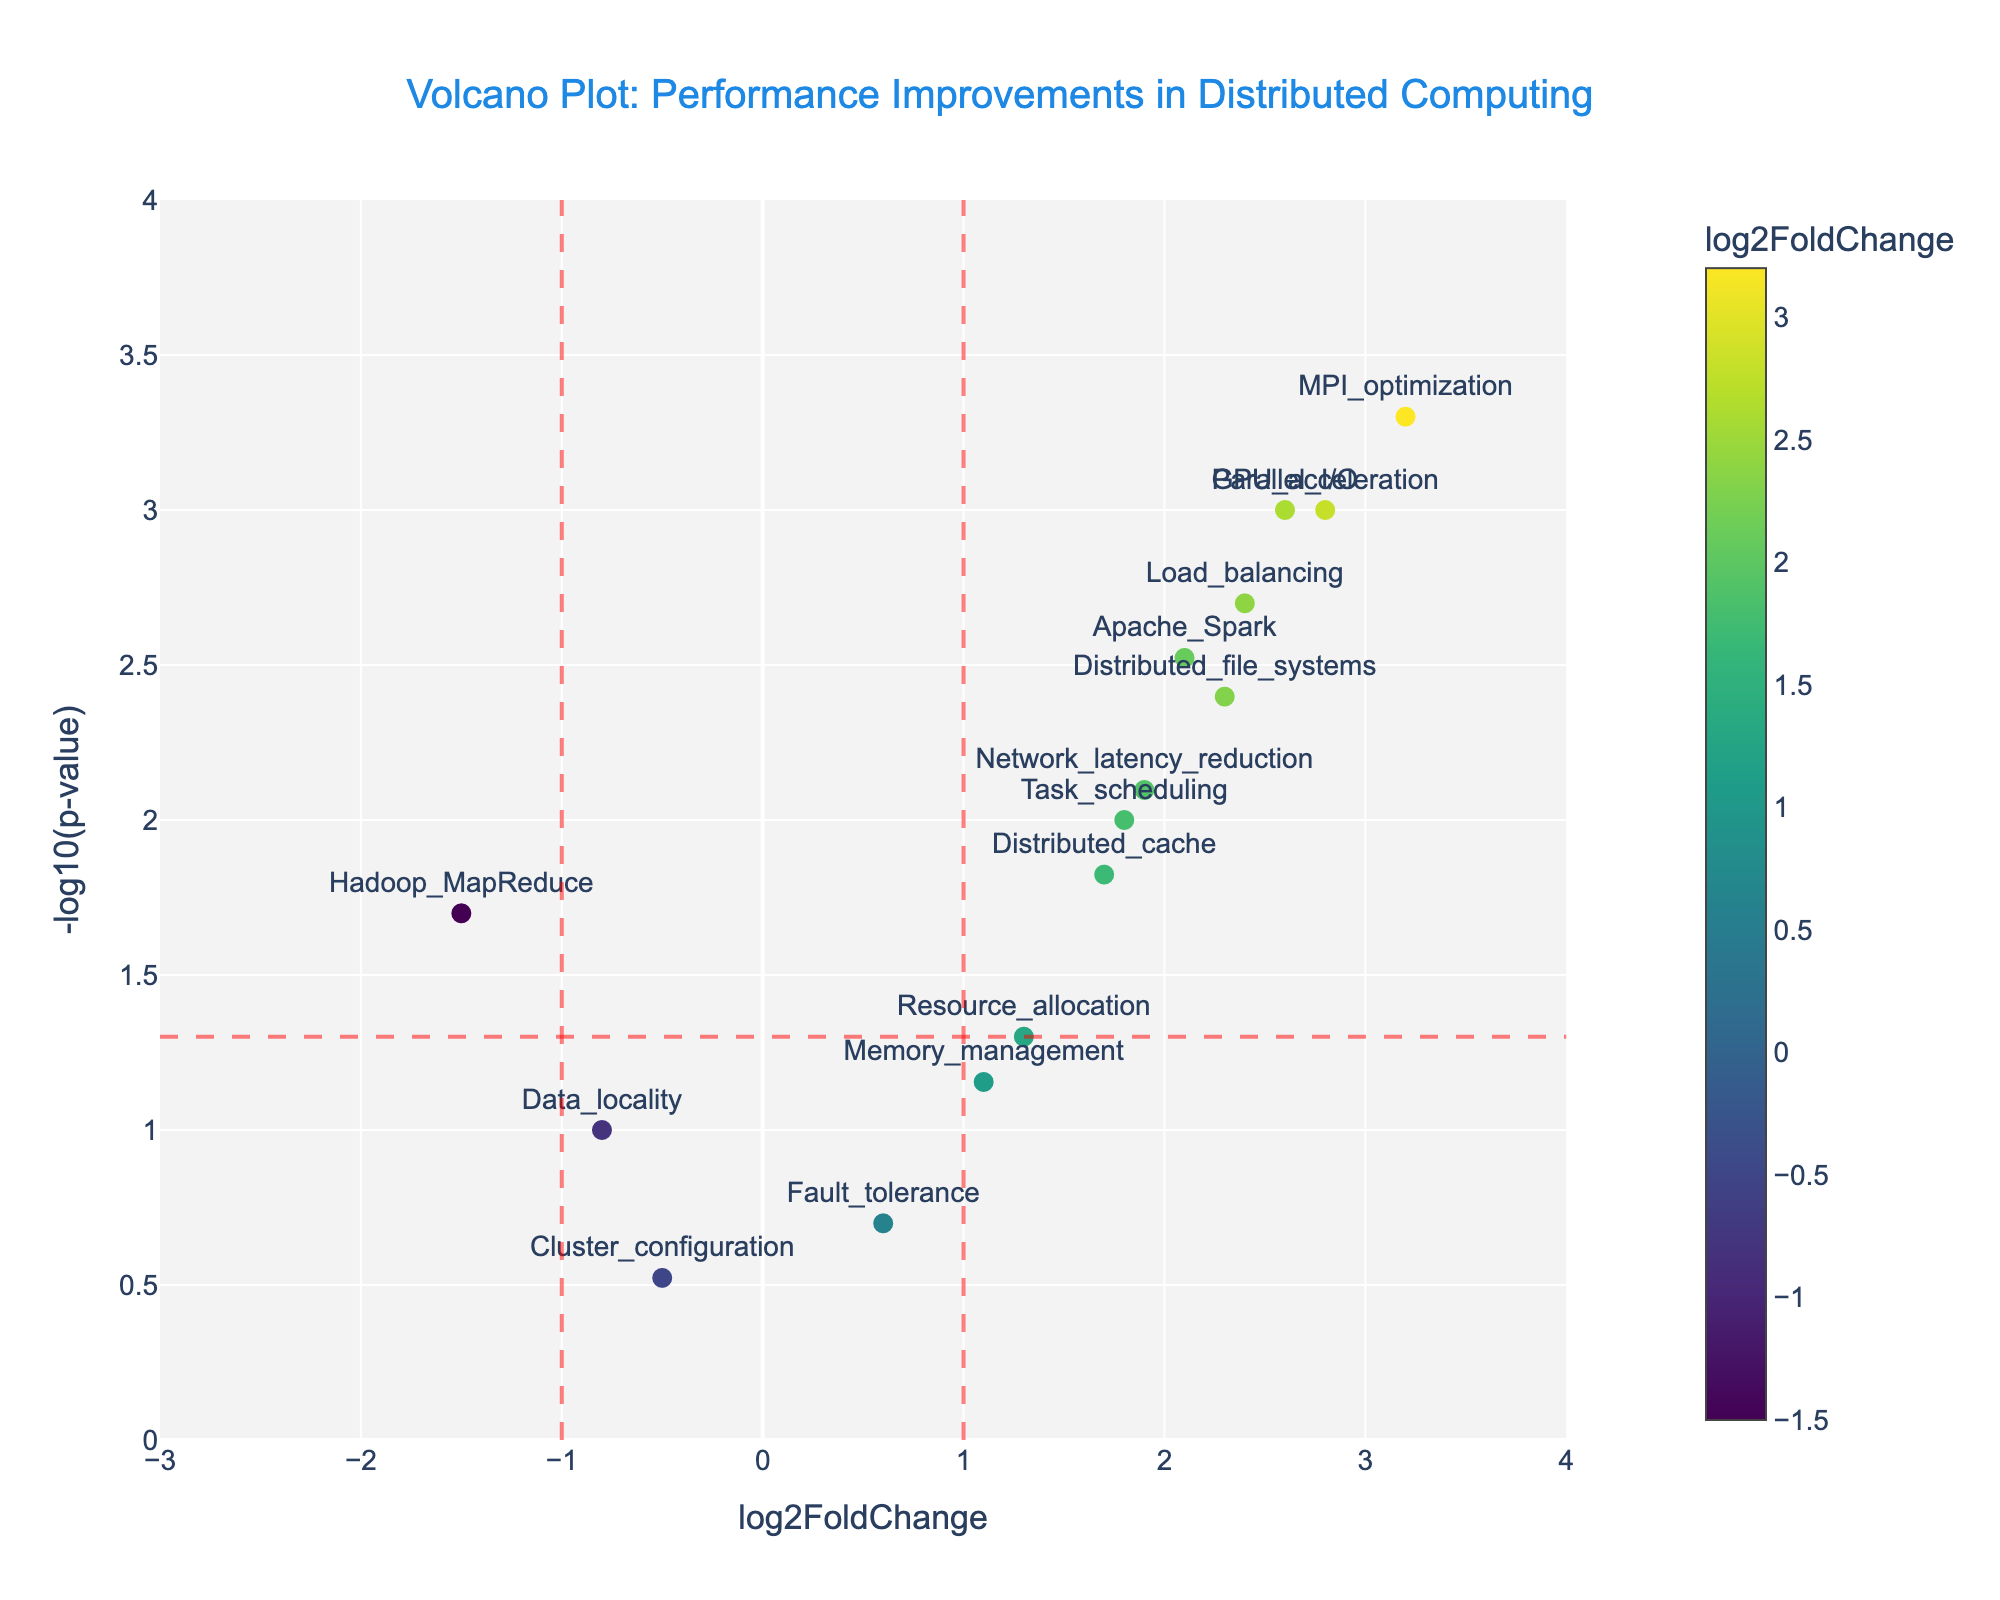Which parameter shows the highest significance in performance improvement? The most significant improvement is indicated by the lowest p-value, thus the highest -log10(p-value). The parameter with the highest y-value is MPI_optimization.
Answer: MPI_optimization What are the threshold lines indicating on the x-axis? The vertical dashed lines on the x-axis are at log2FoldChange = -1 and log2FoldChange = 1, which typically signify the threshold for considering significant changes in performance.
Answer: log2FoldChange = -1 and 1 How many parameters show a log2FoldChange greater than 2? Analyze the data points to see how many lie to the right of log2FoldChange = 2. The points are GPU_acceleration, MPI_optimization, and Parallel_I/O, i.e., 3 points.
Answer: 3 Compare the significance of Apache_Spark and Load_balancing. Both points appear close to each other on the y-axis, but to compare, observe their p-values. Apache_Spark has a p-value of 0.003 and Load_balancing has a p-value of 0.002. Load_balancing has a slightly lower p-value, hence more significant.
Answer: Load_balancing is more significant What does the colorbar indicate? The colorbar shows the range of log2FoldChange values with a Viridis color scale. Data points are colored based on their log2FoldChange values.
Answer: log2FoldChange values Which parameters have a negative log2FoldChange? Points to the left of the y-axis have a negative log2FoldChange. These include Hadoop_MapReduce, Data_locality, and Cluster_configuration.
Answer: Hadoop_MapReduce, Data_locality, Cluster_configuration Which parameter has the least significance? The least significant improvement is indicated by the highest p-value, thus the lowest -log10(p-value). The parameter with the lowest y-value is Cluster_configuration.
Answer: Cluster_configuration How many parameters have significant changes in performance at a 0.05 p-value threshold? Significant performance changes correspond to points above the horizontal line at -log10(p-value) = -log10(0.05). Count the points above this line to find 11 such points.
Answer: 11 Is there any parameter with a log2FoldChange close to zero but still significant? If so, which one? Look for points near the x-axis at log2FoldChange = 0 but above the significance threshold. Resource_allocation with a log2FoldChange of 1.3 and p-value of 0.05 fits this description.
Answer: Resource_allocation 